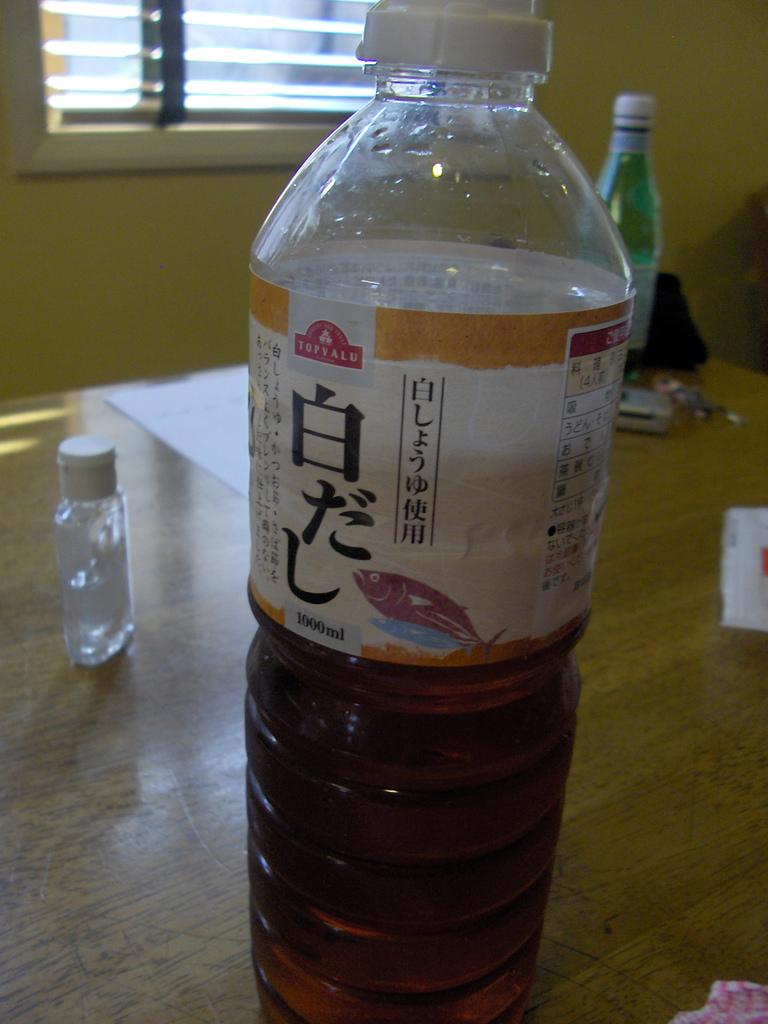How many ml are in the bottle?
Offer a very short reply. 1000. 